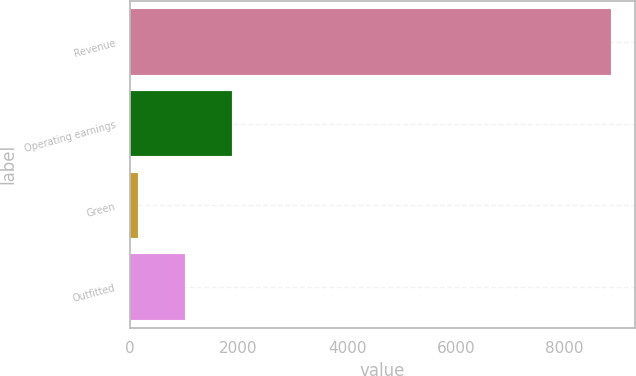<chart> <loc_0><loc_0><loc_500><loc_500><bar_chart><fcel>Revenue<fcel>Operating earnings<fcel>Green<fcel>Outfitted<nl><fcel>8851<fcel>1887.8<fcel>147<fcel>1017.4<nl></chart> 